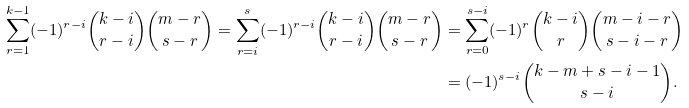Convert formula to latex. <formula><loc_0><loc_0><loc_500><loc_500>\sum _ { r = 1 } ^ { k - 1 } ( - 1 ) ^ { r - i } \binom { k - i } { r - i } \binom { m - r } { s - r } = \sum _ { r = i } ^ { s } ( - 1 ) ^ { r - i } \binom { k - i } { r - i } \binom { m - r } { s - r } & = \sum _ { r = 0 } ^ { s - i } ( - 1 ) ^ { r } \binom { k - i } { r } \binom { m - i - r } { s - i - r } \\ & = ( - 1 ) ^ { s - i } \binom { k - m + s - i - 1 } { s - i } .</formula> 